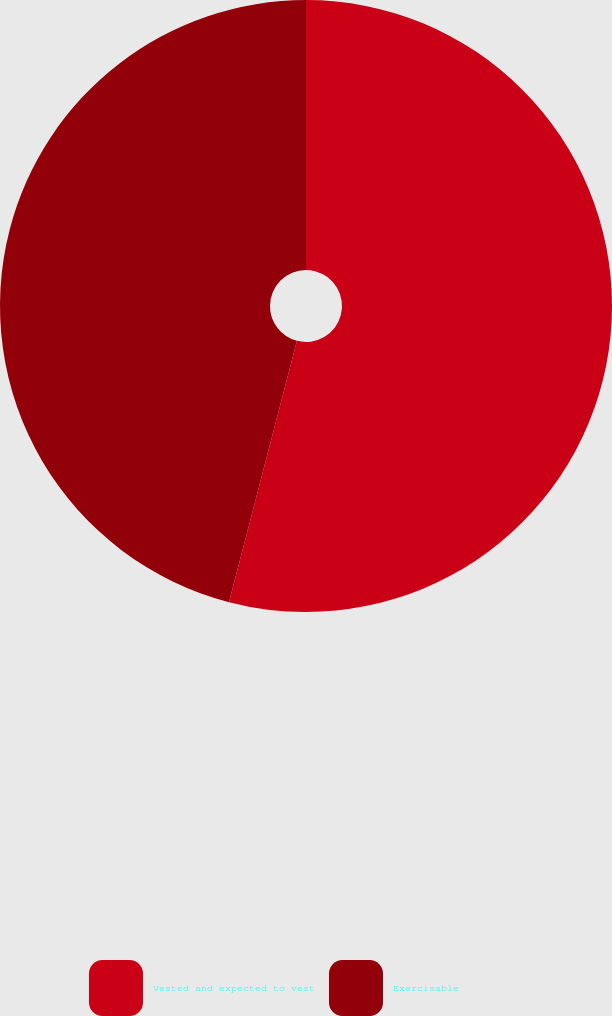Convert chart. <chart><loc_0><loc_0><loc_500><loc_500><pie_chart><fcel>Vested and expected to vest<fcel>Exercisable<nl><fcel>54.05%<fcel>45.95%<nl></chart> 